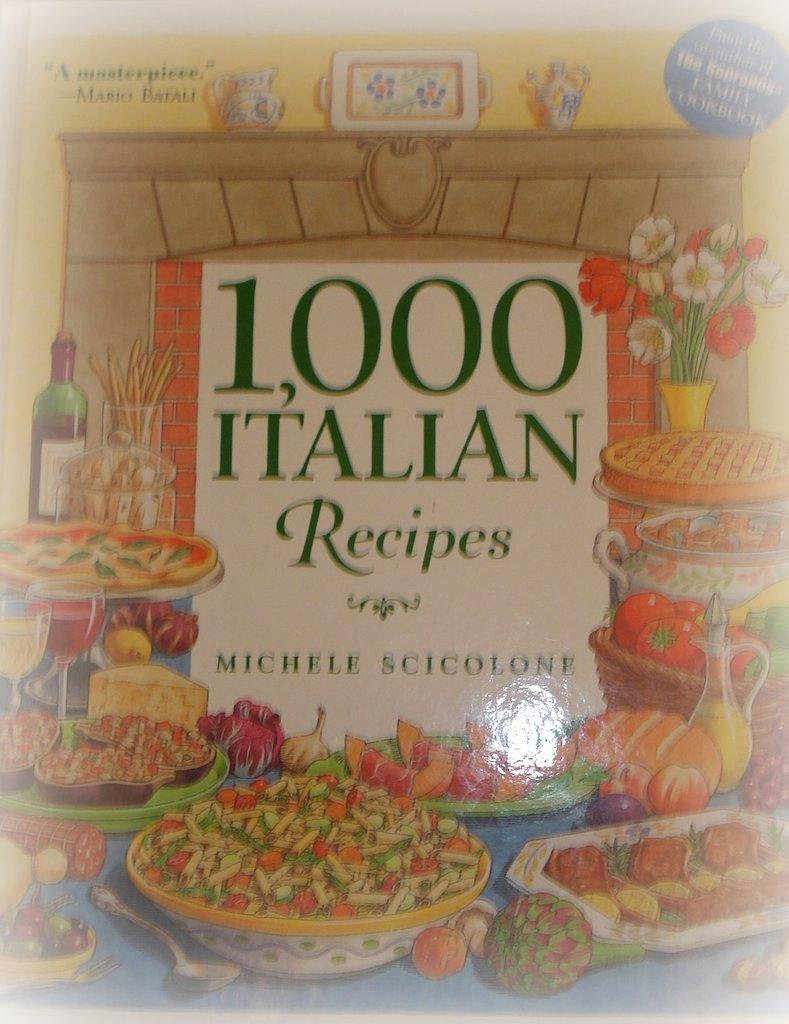Who is the author of this book?
Offer a terse response. Michele scicolone. 